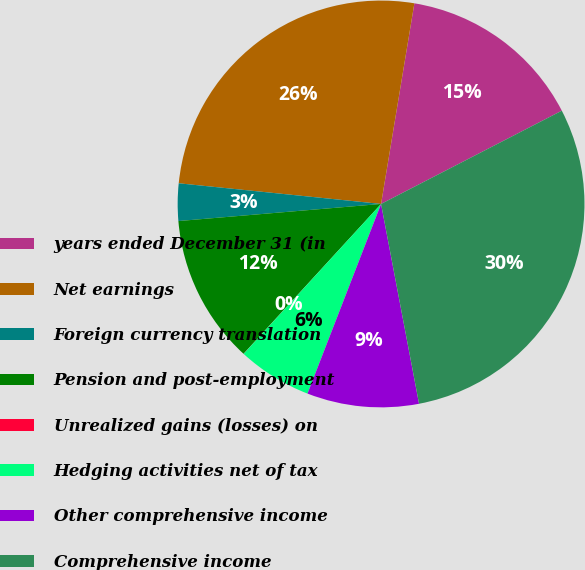<chart> <loc_0><loc_0><loc_500><loc_500><pie_chart><fcel>years ended December 31 (in<fcel>Net earnings<fcel>Foreign currency translation<fcel>Pension and post-employment<fcel>Unrealized gains (losses) on<fcel>Hedging activities net of tax<fcel>Other comprehensive income<fcel>Comprehensive income<nl><fcel>14.8%<fcel>26.0%<fcel>2.96%<fcel>11.84%<fcel>0.01%<fcel>5.92%<fcel>8.88%<fcel>29.59%<nl></chart> 